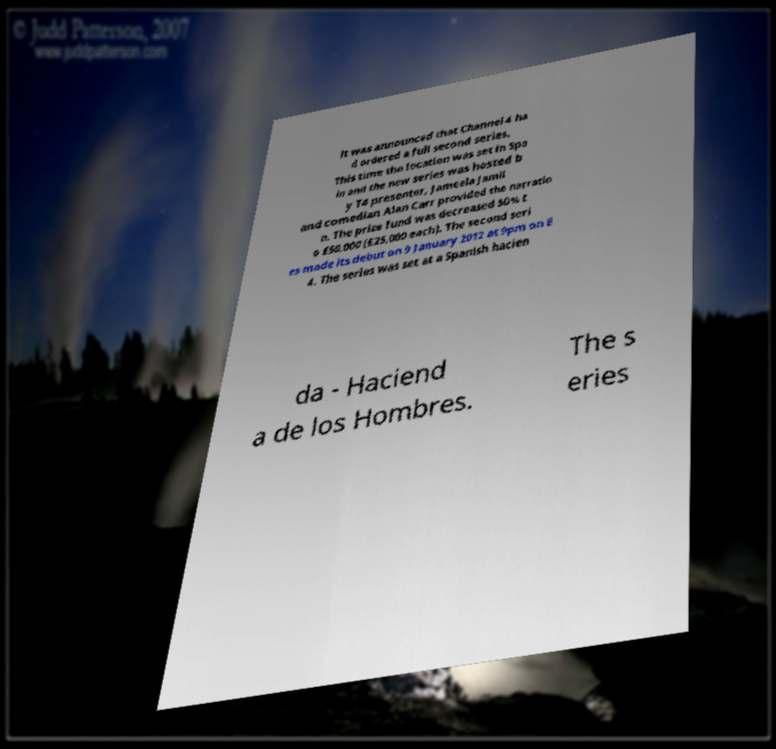Could you assist in decoding the text presented in this image and type it out clearly? it was announced that Channel 4 ha d ordered a full second series. This time the location was set in Spa in and the new series was hosted b y T4 presenter, Jameela Jamil and comedian Alan Carr provided the narratio n. The prize fund was decreased 50% t o £50,000 (£25,000 each). The second seri es made its debut on 9 January 2012 at 9pm on E 4. The series was set at a Spanish hacien da - Haciend a de los Hombres. The s eries 